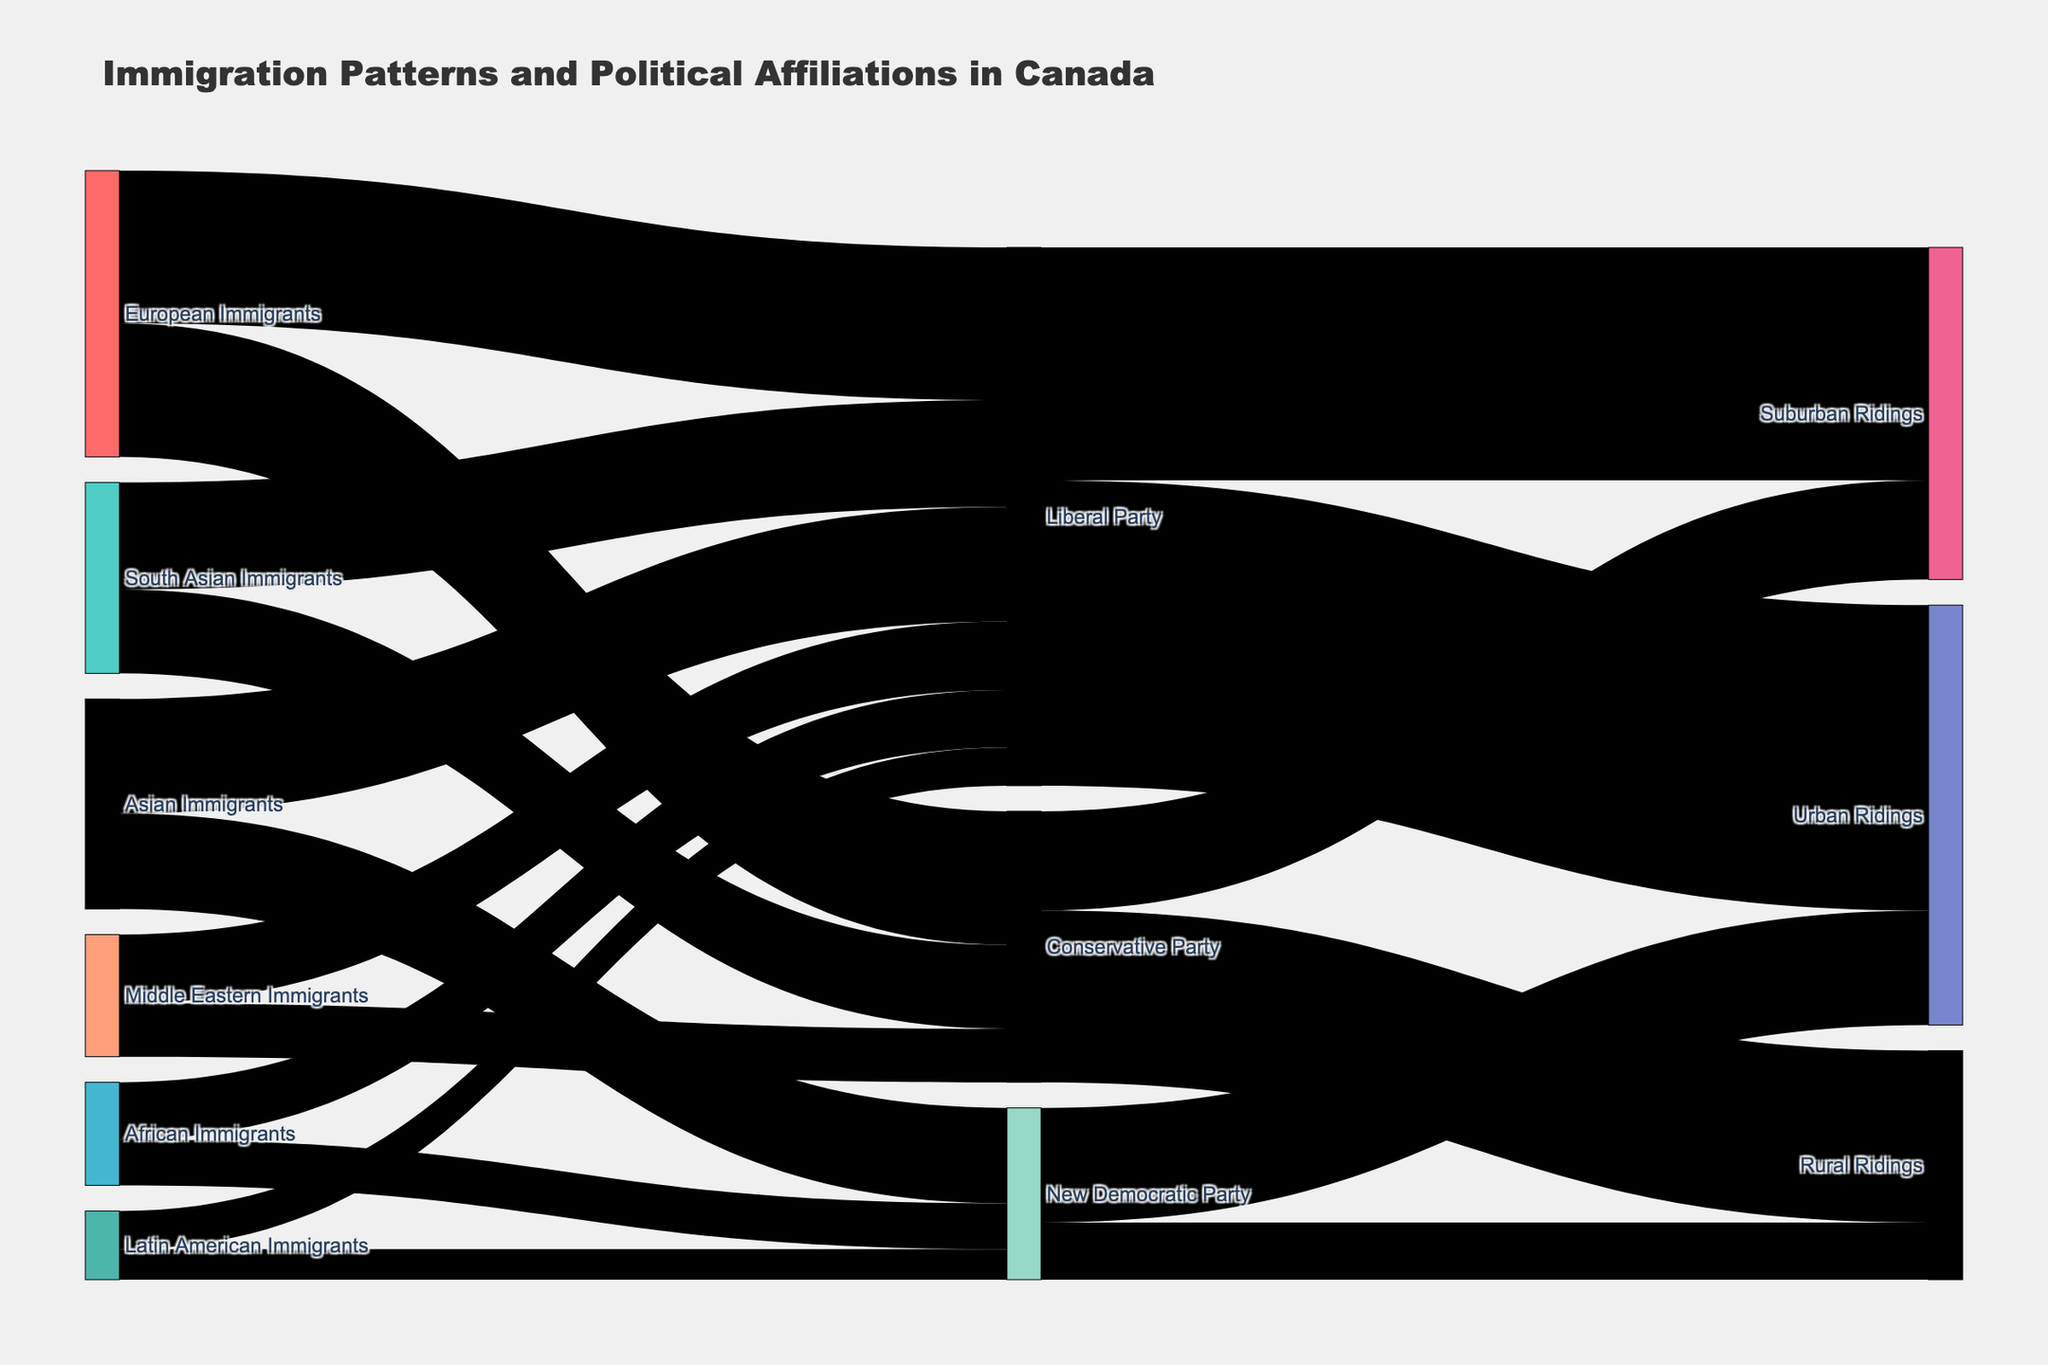What is the title of the Sankey Diagram? The title is prominently displayed at the top of the diagram.
Answer: Immigration Patterns and Political Affiliations in Canada What is the most popular destination political party for European Immigrants? Observing the size of the flows from "European Immigrants" to various political parties, the largest flow goes to the "Liberal Party."
Answer: Liberal Party How many African Immigrants support the New Democratic Party? By locating the node labeled "African Immigrants" and tracing the flow to the "New Democratic Party," the corresponding value is 12,000.
Answer: 12,000 Which type of ridings do the Liberal Party have the most influence in? Track the largest flow originating from the "Liberal Party" to its destination ridings. The highest value flow points to "Urban Ridings".
Answer: Urban Ridings Add up all the immigrants supporting the Conservative Party. How many immigrants support this party? Sum the values originating from different immigrant groups to the "Conservative Party": 35,000 (European) + 22,000 (South Asian) + 14,000 (Middle Eastern) = 71,000.
Answer: 71,000 Which immigrant group has the least representation in the New Democratic Party? Analyze the flows from immigrant groups to the "New Democratic Party," the smallest flow comes from "Latin American Immigrants" with a value of 8,000.
Answer: Latin American Immigrants What is the combined number of immigrants from Asia (including South Asian and Asian Immigrants) who support the Liberal Party? Sum the values from "Asian Immigrants" and "South Asian Immigrants" to the "Liberal Party": 30,000 (Asian) + 28,000 (South Asian) = 58,000.
Answer: 58,000 Compare the support for the Conservative Party in rural ridings versus suburban ridings. In which type does the party have more support? By comparing the flow values from the "Conservative Party" to "Rural Ridings" and "Suburban Ridings," the larger value is for "Rural Ridings" (45,000 vs. 26,000).
Answer: Rural Ridings How does the number of Liberal Party supporters in suburban ridings compare to the total number of New Democratic Party supporters in both rural and urban ridings? Find the value for the Liberal Party's suburban ridings (61,000) and compare it to the sum of the New Democratic Party in rural and urban ridings (15,000 + 30,000 = 45,000). 61,000 is greater than 45,000.
Answer: Higher What percentage of South Asian Immigrants support the Conservative Party? Calculate the percentage by dividing the value for South Asian Immigrants supporting the Conservative Party (22,000) by the total number of South Asian Immigrants supporting any party (28,000 + 22,000 = 50,000), then multiply by 100. (22,000 / 50,000) * 100 = 44%.
Answer: 44% 